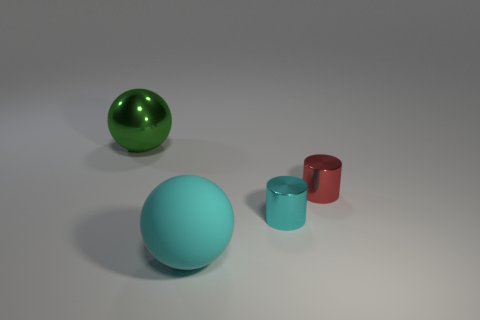What time of day does this scene suggest? The scene does not provide clear indicators of a specific time of day, as it seems to be a controlled environment with consistent artificial lighting, commonly found in studio settings. 